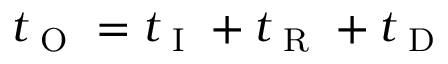Convert formula to latex. <formula><loc_0><loc_0><loc_500><loc_500>t _ { O } = t _ { I } + t _ { R } + t _ { D }</formula> 